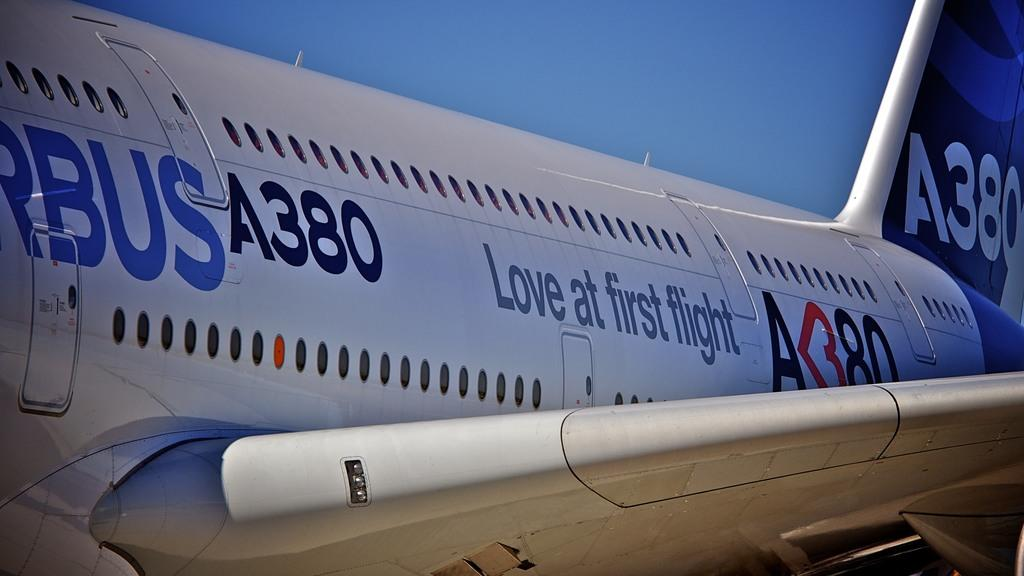Provide a one-sentence caption for the provided image. The A380 airplane is getting ready to take off from the airport. 